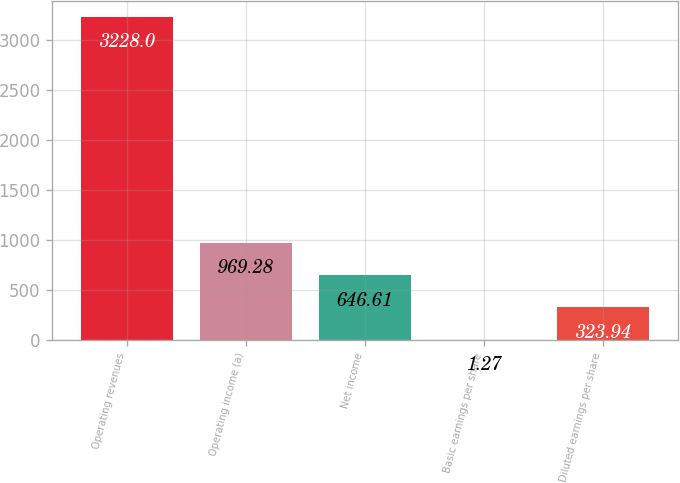<chart> <loc_0><loc_0><loc_500><loc_500><bar_chart><fcel>Operating revenues<fcel>Operating income (a)<fcel>Net income<fcel>Basic earnings per share<fcel>Diluted earnings per share<nl><fcel>3228<fcel>969.28<fcel>646.61<fcel>1.27<fcel>323.94<nl></chart> 